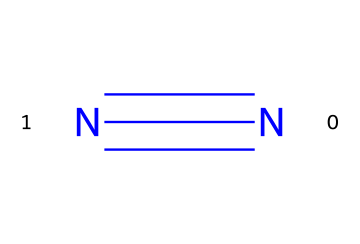What is the molecular formula of the gas represented? The molecule consists of two nitrogen atoms connected by a triple bond. Each nitrogen contributes one atom in the molecular formula. Thus, the molecular formula is N2.
Answer: N2 How many atoms are present in this gas? The structure indicates two nitrogen atoms connected by a triple bond. Therefore, there are 2 atoms in total.
Answer: 2 What type of bond connects the nitrogen atoms in this gas? The SMILES representation shows that the nitrogen atoms are joined by a '#' symbol, indicating a triple bond between them.
Answer: triple bond Is this gas lighter or heavier than air? Nitrogen gas (N2) has a lower molar mass than the average molar mass of air, making it lighter than air.
Answer: lighter What gas is commonly used to inflate baseballs? The structure signifies nitrogen gas, which is commonly utilized for inflating baseballs due to its inert nature and stability.
Answer: nitrogen gas Why is nitrogen gas commonly used instead of oxygen for inflating baseballs? Nitrogen is preferred because it is inert, meaning it does not react with other materials or degrade quickly, while oxygen can cause oxidation and deterioration of the baseball materials.
Answer: inert Will this gas react with the materials of a baseball? Nitrogen is an inert gas, which means it does not readily react with the materials used in making baseballs, ensuring the integrity of the ball over time.
Answer: no 